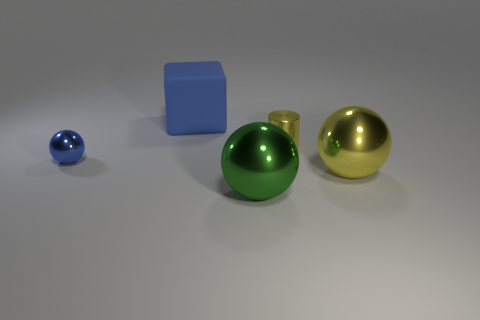Is the color of the large cube the same as the small ball?
Keep it short and to the point. Yes. What shape is the metallic thing left of the large thing that is in front of the large shiny sphere that is on the right side of the yellow cylinder?
Offer a terse response. Sphere. Are there any other things that have the same material as the block?
Ensure brevity in your answer.  No. The yellow object that is the same shape as the green thing is what size?
Ensure brevity in your answer.  Large. There is a thing that is both in front of the tiny blue thing and on the left side of the small yellow object; what is its color?
Keep it short and to the point. Green. Does the tiny cylinder have the same material as the block behind the tiny yellow metallic object?
Keep it short and to the point. No. Are there fewer tiny metal objects that are in front of the metallic cylinder than small yellow cylinders?
Offer a very short reply. No. What number of other objects are the same shape as the tiny yellow thing?
Make the answer very short. 0. Is there anything else of the same color as the tiny shiny ball?
Your answer should be very brief. Yes. Does the cylinder have the same color as the big sphere that is behind the green shiny ball?
Provide a short and direct response. Yes. 